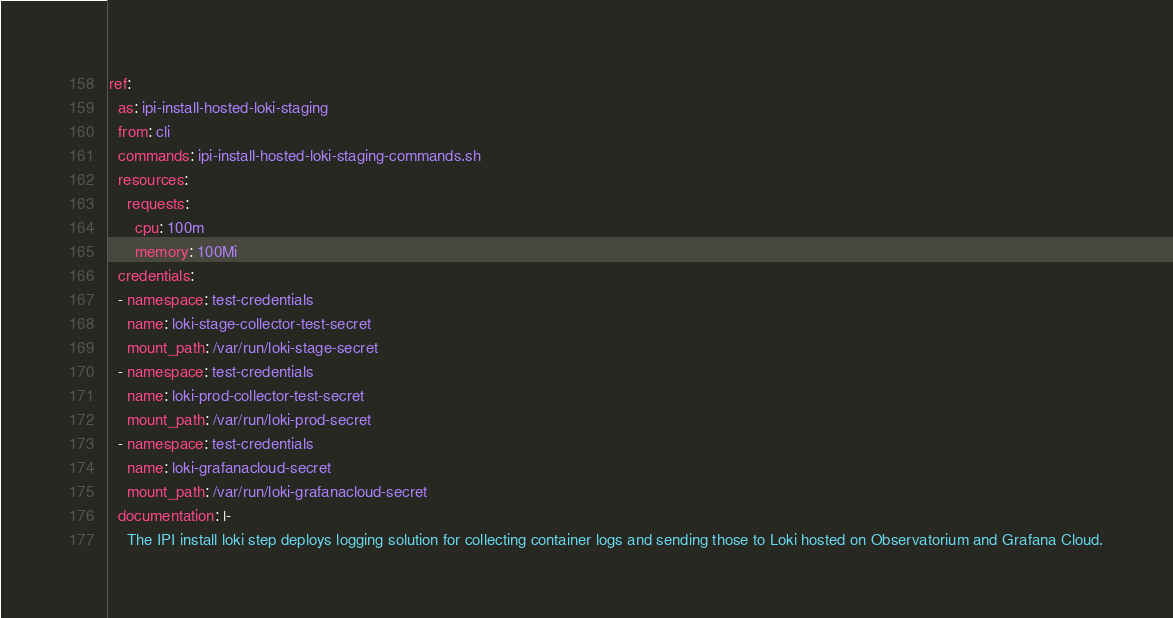Convert code to text. <code><loc_0><loc_0><loc_500><loc_500><_YAML_>ref:
  as: ipi-install-hosted-loki-staging
  from: cli
  commands: ipi-install-hosted-loki-staging-commands.sh
  resources:
    requests:
      cpu: 100m
      memory: 100Mi
  credentials:
  - namespace: test-credentials
    name: loki-stage-collector-test-secret
    mount_path: /var/run/loki-stage-secret
  - namespace: test-credentials
    name: loki-prod-collector-test-secret
    mount_path: /var/run/loki-prod-secret
  - namespace: test-credentials
    name: loki-grafanacloud-secret
    mount_path: /var/run/loki-grafanacloud-secret
  documentation: |-
    The IPI install loki step deploys logging solution for collecting container logs and sending those to Loki hosted on Observatorium and Grafana Cloud.
</code> 